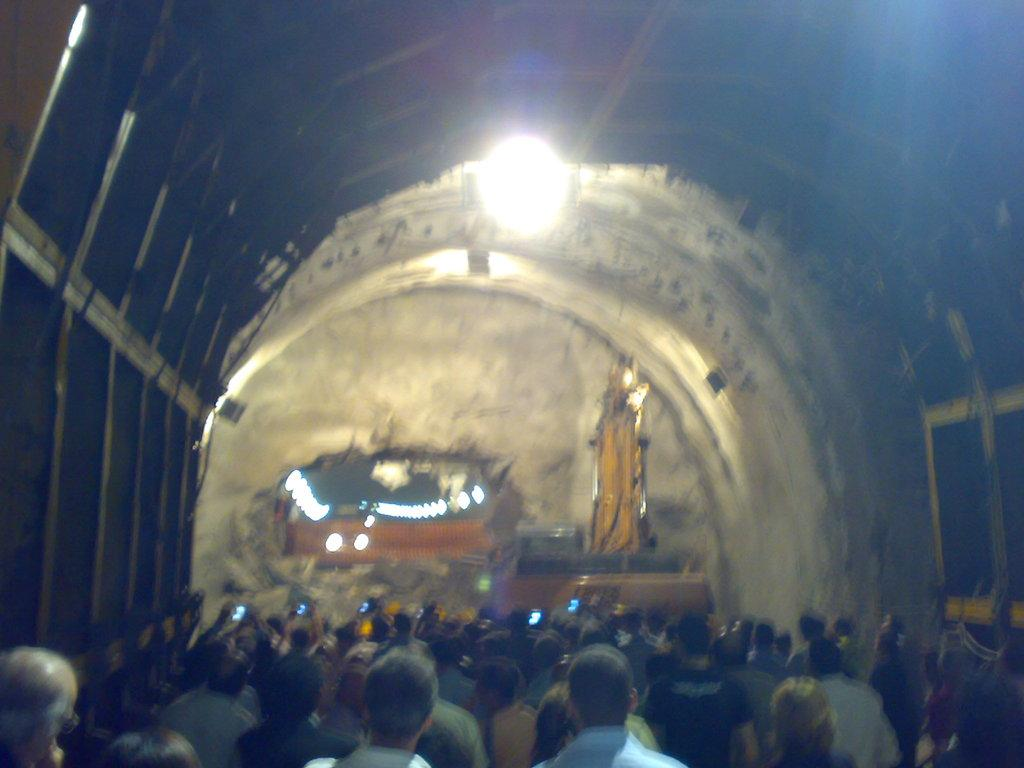What is the main subject of the image? The main subject of the image is a crane excavating. What is the crane doing in the image? The crane is working on a building. Are there any people visible in the image? Yes, there are persons visible at the bottom of the image. What type of card is being used to plant seeds in the image? There is no card or seeds present in the image; it features a crane working on a building. What attraction is visible in the background of the image? There is no attraction visible in the image; it focuses on the crane and the building. 